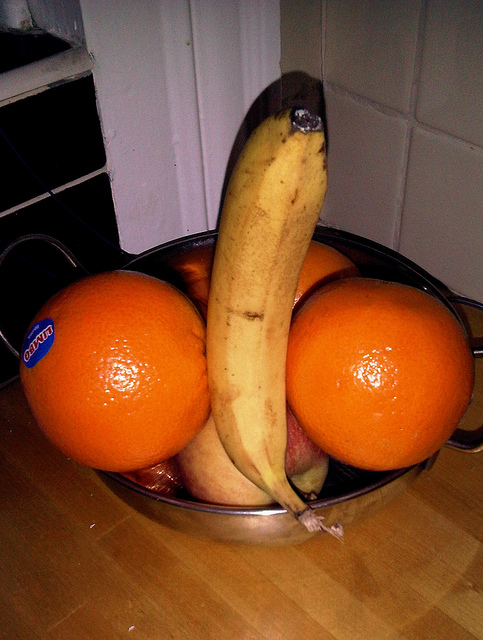Identify the text contained in this image. LIMRO 